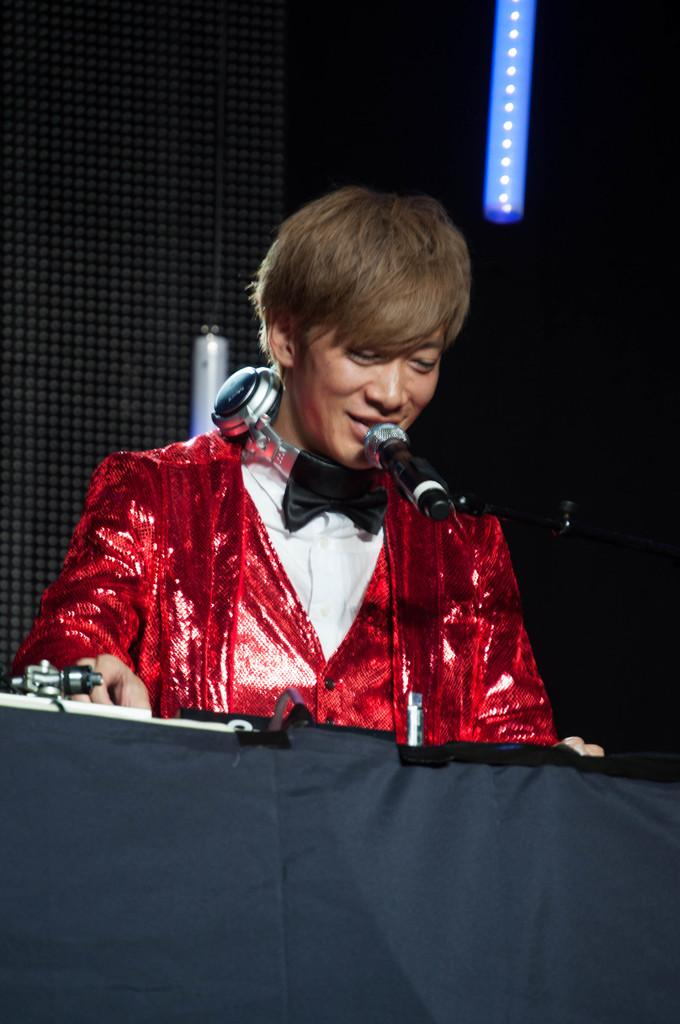Who is present in the image? There is a man in the image. What is the man wearing on his head? The man is wearing a headset. What device is in front of the man? There is a microphone in front of the man. What can be seen in the background of the image? There is light in the background of the image. How much tax does the wax pay in the image? There is no mention of tax or wax in the image; it features a man wearing a headset and using a microphone. 